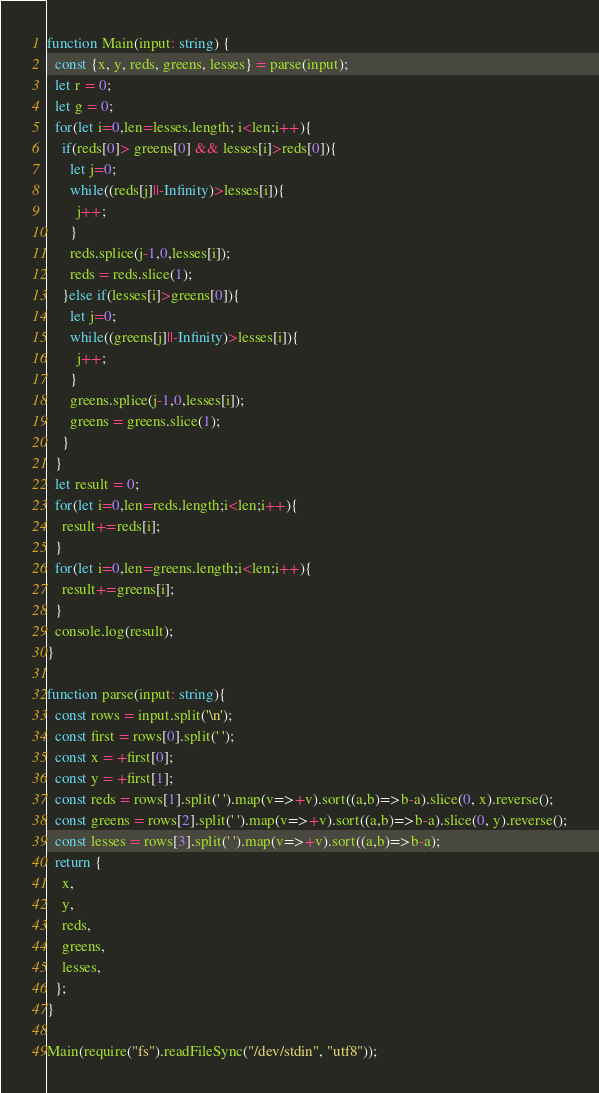<code> <loc_0><loc_0><loc_500><loc_500><_TypeScript_>function Main(input: string) {
  const {x, y, reds, greens, lesses} = parse(input);
  let r = 0;
  let g = 0;
  for(let i=0,len=lesses.length; i<len;i++){
    if(reds[0]> greens[0] && lesses[i]>reds[0]){
      let j=0;
      while((reds[j]||-Infinity)>lesses[i]){
        j++;
      }
      reds.splice(j-1,0,lesses[i]);
      reds = reds.slice(1);
    }else if(lesses[i]>greens[0]){
      let j=0;
      while((greens[j]||-Infinity)>lesses[i]){
        j++;
      }
      greens.splice(j-1,0,lesses[i]);
      greens = greens.slice(1);
    }
  }
  let result = 0;
  for(let i=0,len=reds.length;i<len;i++){
    result+=reds[i];
  }
  for(let i=0,len=greens.length;i<len;i++){
    result+=greens[i];
  }
  console.log(result);
}

function parse(input: string){
  const rows = input.split('\n');
  const first = rows[0].split(' ');
  const x = +first[0];
  const y = +first[1];
  const reds = rows[1].split(' ').map(v=>+v).sort((a,b)=>b-a).slice(0, x).reverse();
  const greens = rows[2].split(' ').map(v=>+v).sort((a,b)=>b-a).slice(0, y).reverse();
  const lesses = rows[3].split(' ').map(v=>+v).sort((a,b)=>b-a);
  return {
    x,
    y,
    reds,
    greens,
    lesses,
  };
}

Main(require("fs").readFileSync("/dev/stdin", "utf8"));
</code> 